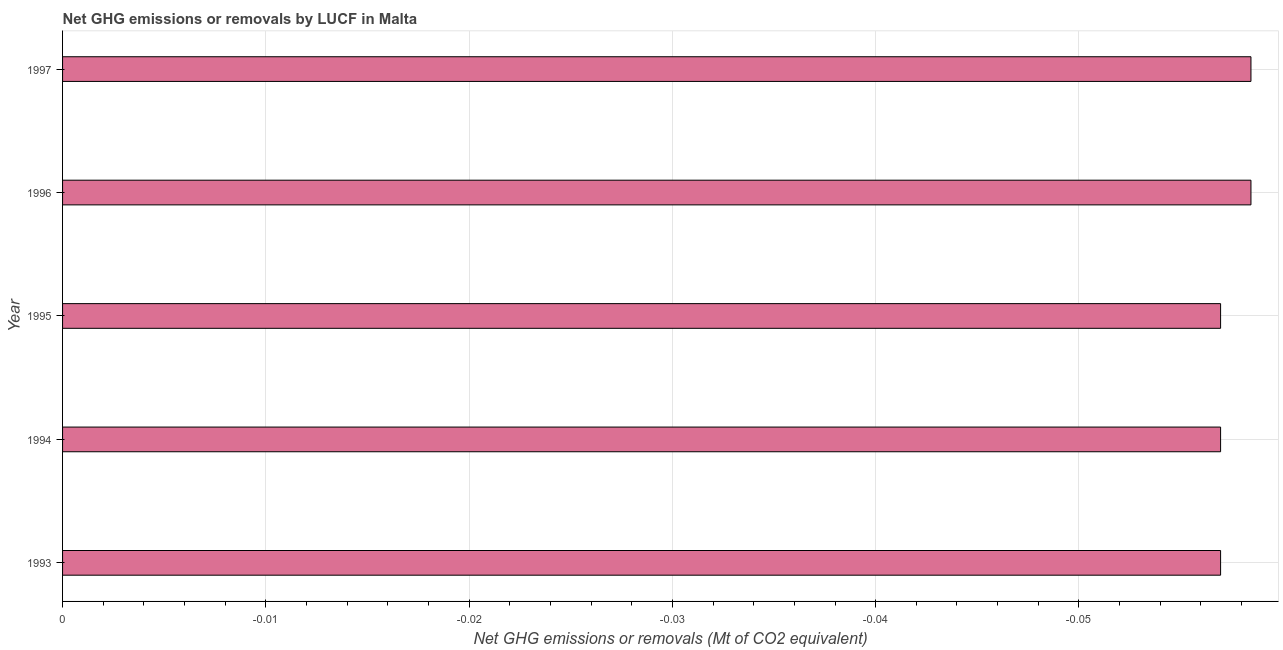Does the graph contain any zero values?
Provide a short and direct response. Yes. What is the title of the graph?
Make the answer very short. Net GHG emissions or removals by LUCF in Malta. What is the label or title of the X-axis?
Provide a succinct answer. Net GHG emissions or removals (Mt of CO2 equivalent). What is the label or title of the Y-axis?
Make the answer very short. Year. What is the ghg net emissions or removals in 1994?
Your answer should be compact. 0. What is the sum of the ghg net emissions or removals?
Your response must be concise. 0. In how many years, is the ghg net emissions or removals greater than -0.032 Mt?
Offer a very short reply. 0. How many bars are there?
Give a very brief answer. 0. How many years are there in the graph?
Make the answer very short. 5. What is the difference between two consecutive major ticks on the X-axis?
Ensure brevity in your answer.  0.01. What is the Net GHG emissions or removals (Mt of CO2 equivalent) in 1993?
Ensure brevity in your answer.  0. What is the Net GHG emissions or removals (Mt of CO2 equivalent) in 1995?
Provide a succinct answer. 0. What is the Net GHG emissions or removals (Mt of CO2 equivalent) of 1997?
Your answer should be very brief. 0. 